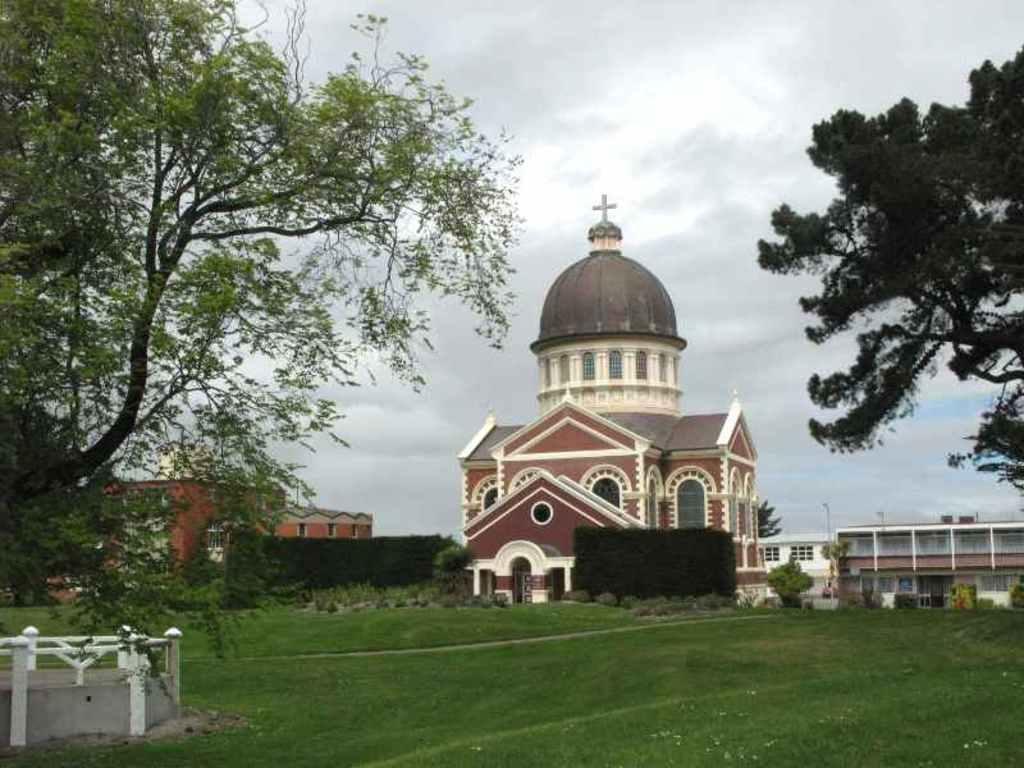In one or two sentences, can you explain what this image depicts? At the bottom of the picture,we see the grass. On the left side, we see the railing and the trees. On the right side, we see the trees. In the middle of the picture, we see the church. There are trees, shrubs, street lights and buildings in the background. At the top, we see the sky. 